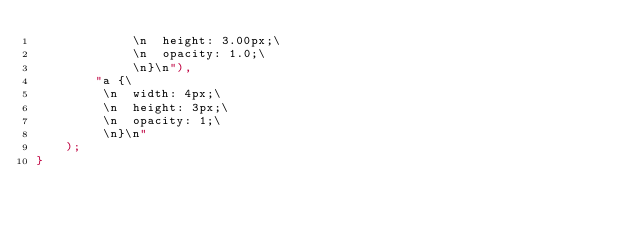<code> <loc_0><loc_0><loc_500><loc_500><_Rust_>             \n  height: 3.00px;\
             \n  opacity: 1.0;\
             \n}\n"),
        "a {\
         \n  width: 4px;\
         \n  height: 3px;\
         \n  opacity: 1;\
         \n}\n"
    );
}
</code> 